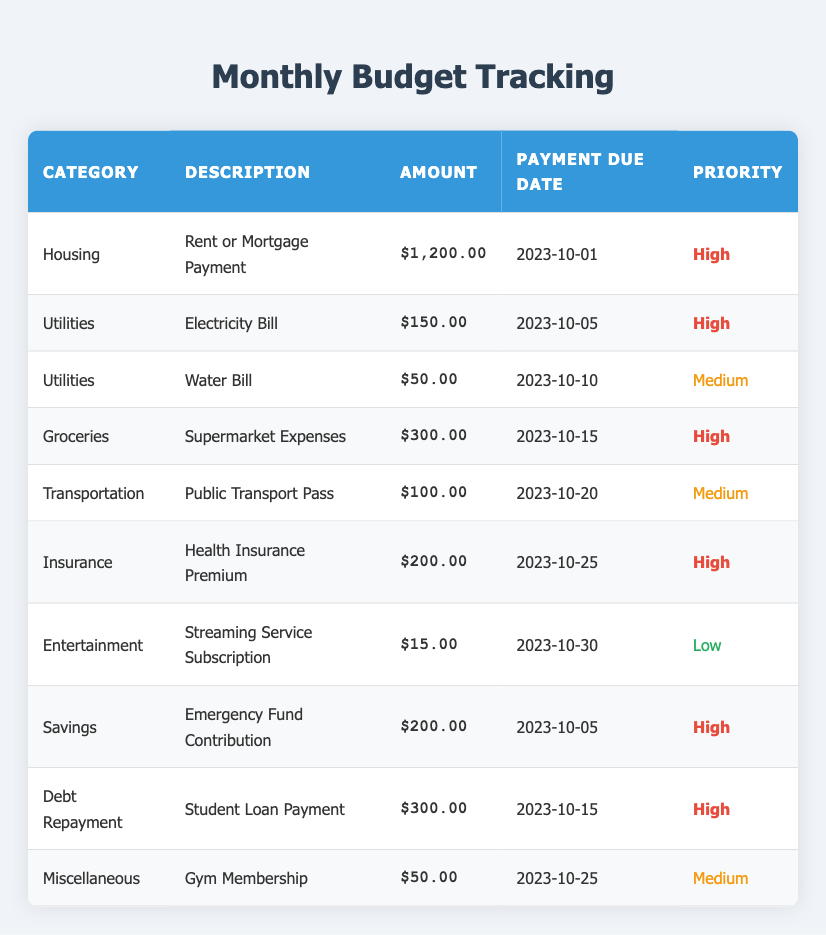What is the amount for the Rent or Mortgage Payment? The Rent or Mortgage Payment is clearly listed under the Housing category, and the amount is provided in the Amount column next to it. The value is $1200.00.
Answer: $1200.00 How many categories have a high priority? To identify categories with high priority, I will review the Priority column and count the instances marked as "High." Upon reviewing, there are six instances: Housing, Electricity Bill, Groceries, Health Insurance, Emergency Fund Contribution, and Student Loan Payment.
Answer: 6 What is the total amount for all Utilities? I will sum the amounts under the Utilities category. The Electricity Bill is $150.00, and the Water Bill is $50.00. Adding them together gives: $150.00 + $50.00 = $200.00.
Answer: $200.00 Is there any expense less than $20? I will check the Amount column for any values less than $20. The Streaming Service Subscription is listed at $15.00, which is indeed less than $20. Therefore, there is an expense less than $20.
Answer: Yes What is the total amount of expenses due before October 15, 2023? I will identify all the payments due by October 15. The due dates include October 1 (Rent), October 5 (Electricity and Savings), and October 10 (Water), and October 15 (Groceries, and Debt Repayment). The respective amounts are $1200.00 + $150.00 + $200.00 + $50.00 + $300.00 + $300.00. Now, summing these values, we have: $1200.00 + $150.00 + $200.00 + $50.00 + $300.00 = $1900.00.
Answer: $1900.00 Which categories have their payment due on the same date? I will inspect the Payment Due Date column for matches. The due date of October 5 applies to both the Electricity Bill and the Emergency Fund Contribution. Therefore, these categories share the same payment due date.
Answer: Electricity, Savings 